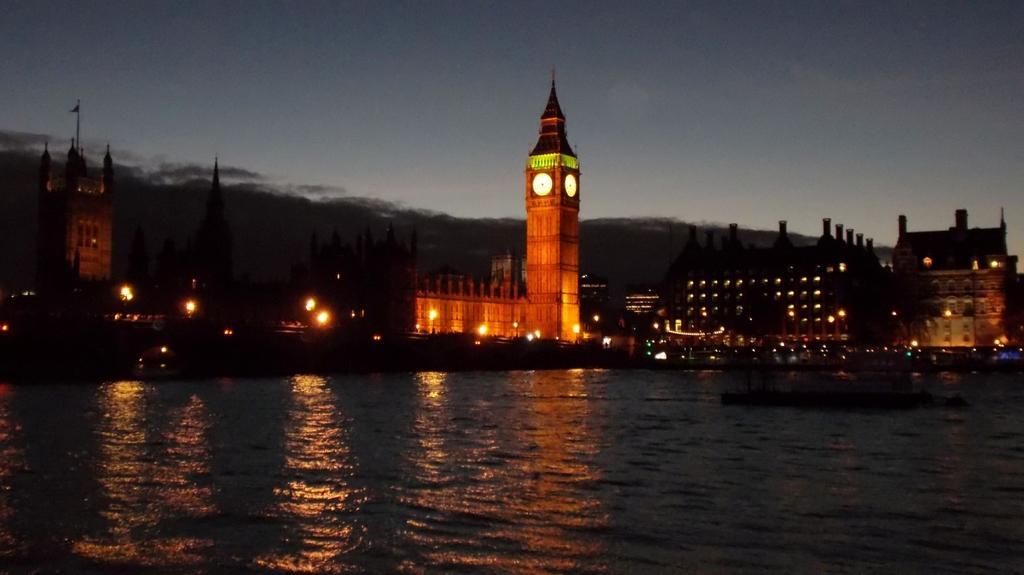What type of natural feature can be seen in the image? There is a river in the image. What man-made structures are present in the image? There are buildings and a clock tower in the image. What color lights are visible in the image? Yellow color lights are present in the image. What can be seen in the background of the image? There is a sky visible in the background of the image, with clouds present. Can you tell me how many sponges are floating in the river in the image? There are no sponges present in the image; it features a river, buildings, a clock tower, and yellow lights. What type of jellyfish can be seen swimming in the sky in the image? There are no jellyfish present in the image; it features a river, buildings, a clock tower, and yellow lights, with a sky visible in the background that contains clouds. 